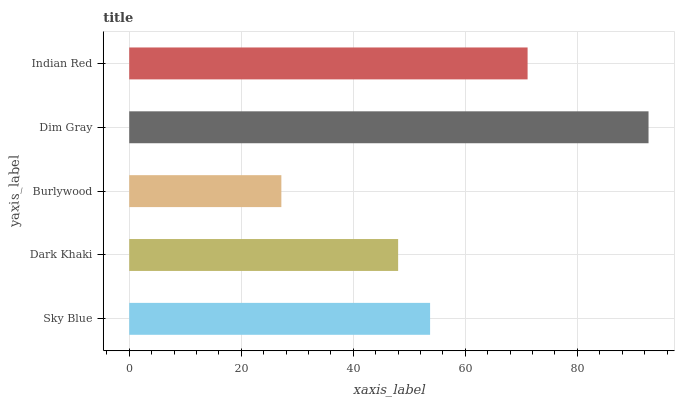Is Burlywood the minimum?
Answer yes or no. Yes. Is Dim Gray the maximum?
Answer yes or no. Yes. Is Dark Khaki the minimum?
Answer yes or no. No. Is Dark Khaki the maximum?
Answer yes or no. No. Is Sky Blue greater than Dark Khaki?
Answer yes or no. Yes. Is Dark Khaki less than Sky Blue?
Answer yes or no. Yes. Is Dark Khaki greater than Sky Blue?
Answer yes or no. No. Is Sky Blue less than Dark Khaki?
Answer yes or no. No. Is Sky Blue the high median?
Answer yes or no. Yes. Is Sky Blue the low median?
Answer yes or no. Yes. Is Burlywood the high median?
Answer yes or no. No. Is Dim Gray the low median?
Answer yes or no. No. 